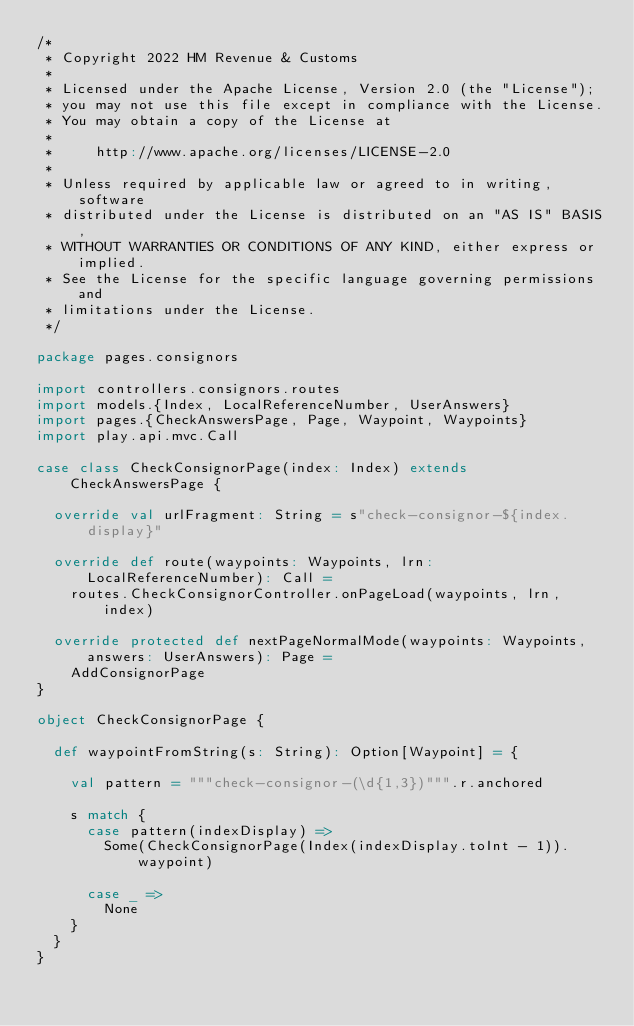Convert code to text. <code><loc_0><loc_0><loc_500><loc_500><_Scala_>/*
 * Copyright 2022 HM Revenue & Customs
 *
 * Licensed under the Apache License, Version 2.0 (the "License");
 * you may not use this file except in compliance with the License.
 * You may obtain a copy of the License at
 *
 *     http://www.apache.org/licenses/LICENSE-2.0
 *
 * Unless required by applicable law or agreed to in writing, software
 * distributed under the License is distributed on an "AS IS" BASIS,
 * WITHOUT WARRANTIES OR CONDITIONS OF ANY KIND, either express or implied.
 * See the License for the specific language governing permissions and
 * limitations under the License.
 */

package pages.consignors

import controllers.consignors.routes
import models.{Index, LocalReferenceNumber, UserAnswers}
import pages.{CheckAnswersPage, Page, Waypoint, Waypoints}
import play.api.mvc.Call

case class CheckConsignorPage(index: Index) extends CheckAnswersPage {

  override val urlFragment: String = s"check-consignor-${index.display}"

  override def route(waypoints: Waypoints, lrn: LocalReferenceNumber): Call =
    routes.CheckConsignorController.onPageLoad(waypoints, lrn, index)

  override protected def nextPageNormalMode(waypoints: Waypoints, answers: UserAnswers): Page =
    AddConsignorPage
}

object CheckConsignorPage {

  def waypointFromString(s: String): Option[Waypoint] = {

    val pattern = """check-consignor-(\d{1,3})""".r.anchored

    s match {
      case pattern(indexDisplay) =>
        Some(CheckConsignorPage(Index(indexDisplay.toInt - 1)).waypoint)

      case _ =>
        None
    }
  }
}

</code> 